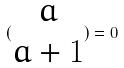<formula> <loc_0><loc_0><loc_500><loc_500>( \begin{matrix} a \\ a + 1 \end{matrix} ) = 0</formula> 